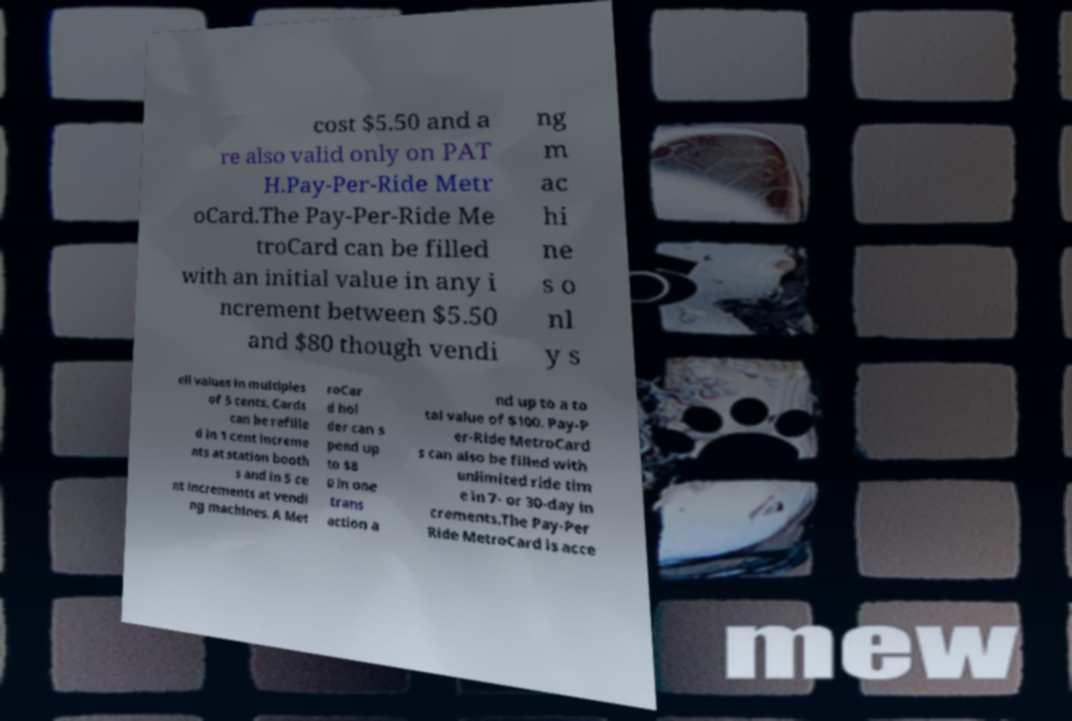Please read and relay the text visible in this image. What does it say? cost $5.50 and a re also valid only on PAT H.Pay-Per-Ride Metr oCard.The Pay-Per-Ride Me troCard can be filled with an initial value in any i ncrement between $5.50 and $80 though vendi ng m ac hi ne s o nl y s ell values in multiples of 5 cents. Cards can be refille d in 1 cent increme nts at station booth s and in 5 ce nt increments at vendi ng machines. A Met roCar d hol der can s pend up to $8 0 in one trans action a nd up to a to tal value of $100. Pay-P er-Ride MetroCard s can also be filled with unlimited ride tim e in 7- or 30-day in crements.The Pay-Per Ride MetroCard is acce 